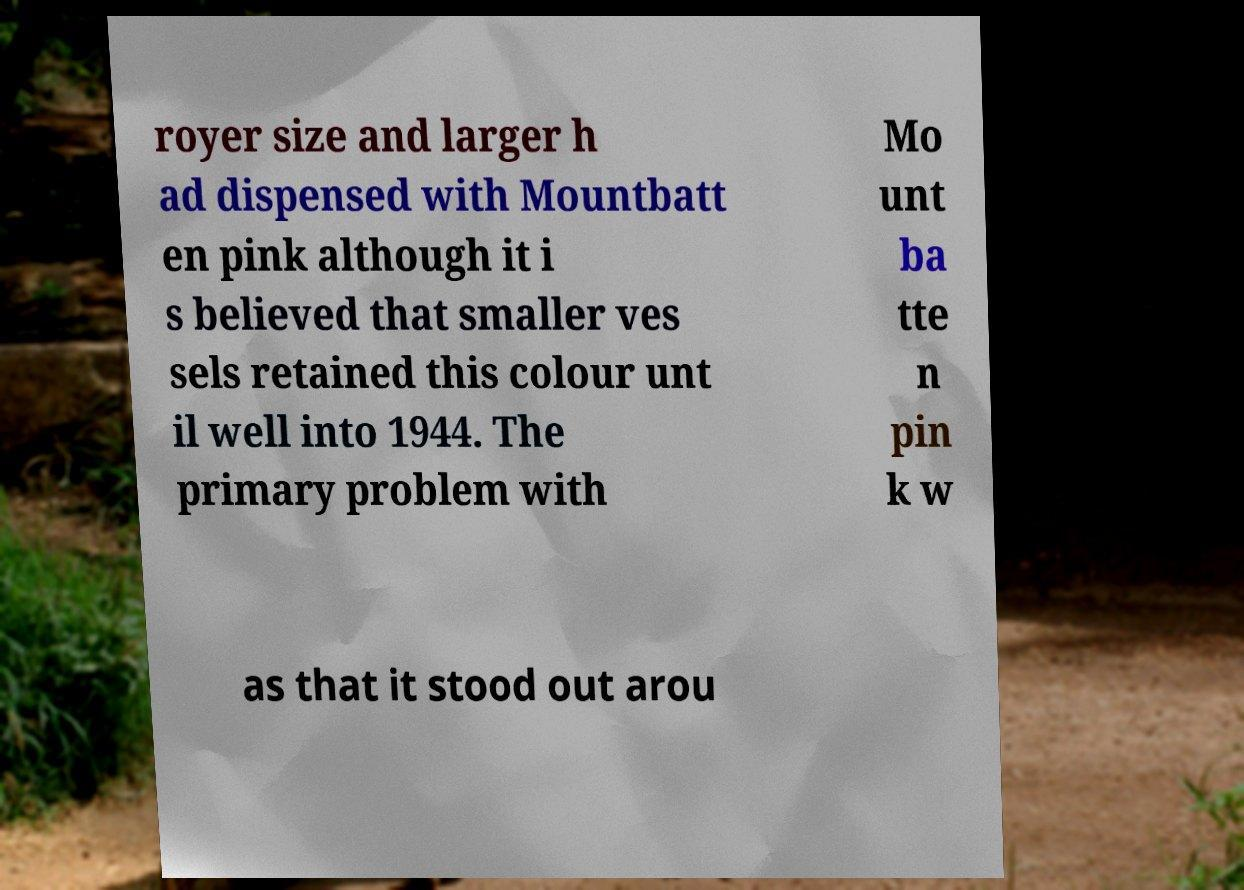What messages or text are displayed in this image? I need them in a readable, typed format. royer size and larger h ad dispensed with Mountbatt en pink although it i s believed that smaller ves sels retained this colour unt il well into 1944. The primary problem with Mo unt ba tte n pin k w as that it stood out arou 